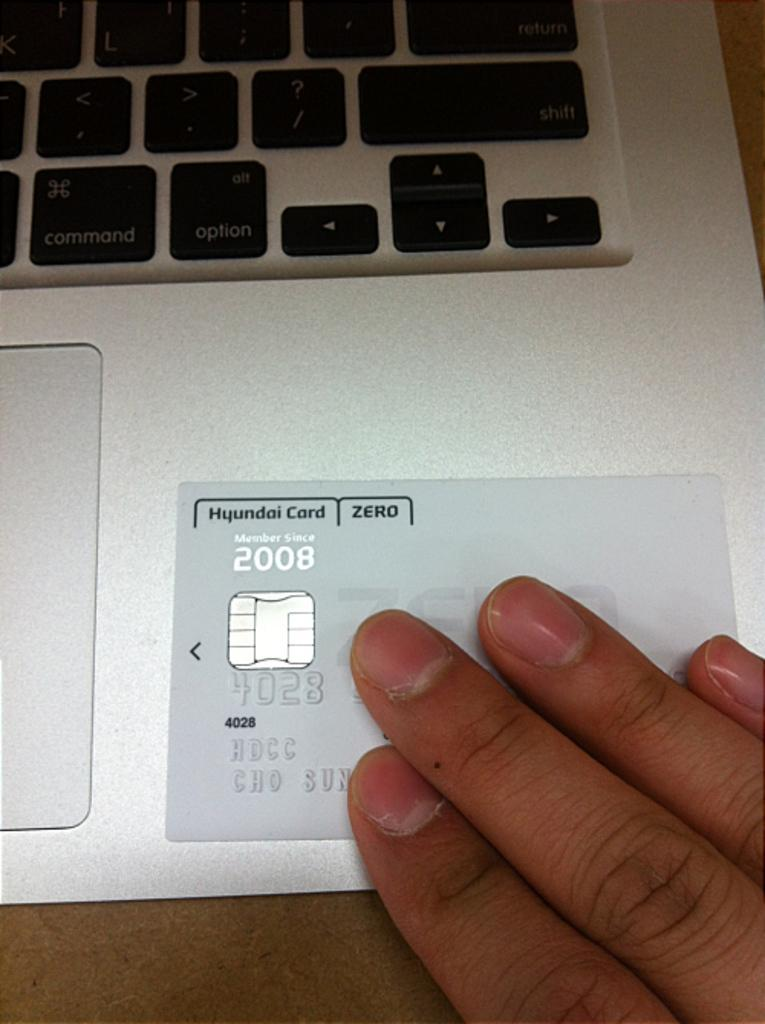<image>
Give a short and clear explanation of the subsequent image. A Hyundai card placed on a silver laptop. 